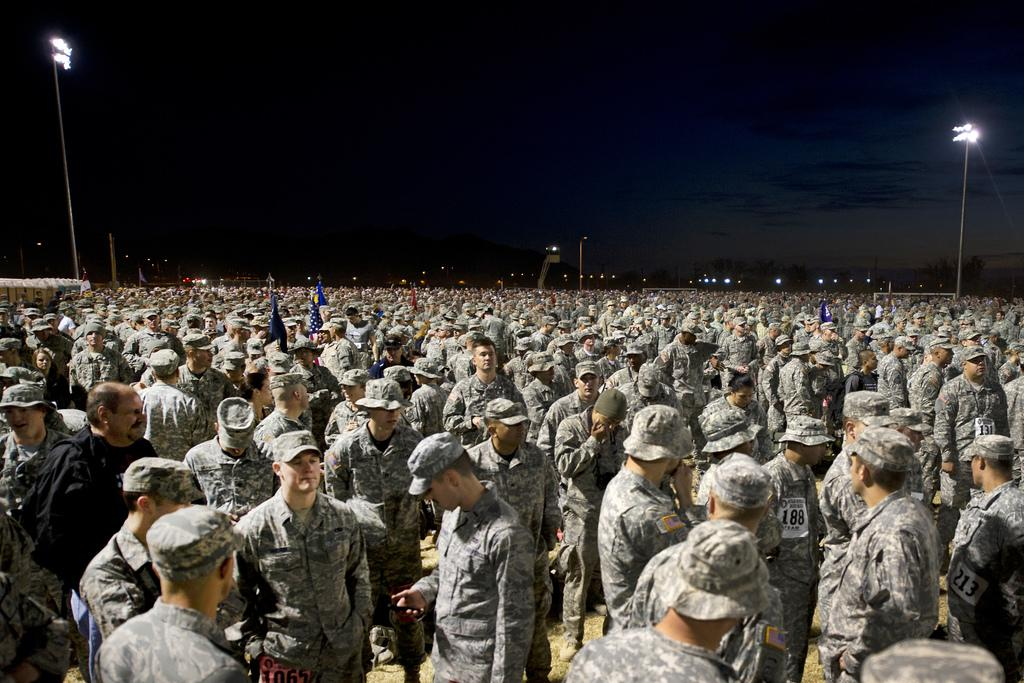What is the main subject of the image? The main subject of the image is a group of people. What can be observed about the attire of the people in the image? Most of the people are wearing military dress and caps. What other objects can be seen in the image? There are light poles and flags in the image. What type of jewel is being used as a chess piece in the image? There is no chess or jewel present in the image; it features a group of people wearing military dress and caps, with light poles and flags in the background. --- Facts: 1. There is a car in the image. 2. The car is parked on the street. 3. There are trees on the side of the street. 4. The sky is visible in the image. 5. There is a traffic light in the image. Absurd Topics: parrot, sandcastle, volcano Conversation: What is the main subject of the image? The main subject of the image is a car. Where is the car located in the image? The car is parked on the street. What can be seen on the side of the street? There are trees on the side of the street. What is visible in the background of the image? The sky is visible in the image. What traffic control device is present in the image? There is a traffic light in the image. Reasoning: Let's think step by step in order to produce the conversation. We start by identifying the main subject of the image, which is the car. Then, we describe the location of the car, noting that it is parked on the street. Next, we mention the presence of trees on the side of the street. We then describe the background of the image, which includes the sky. Finally, we acknowledge the presence of a traffic light in the image. Absurd Question/Answer: Can you tell me how many parrots are sitting on the sandcastle in the image? There are no parrots or sandcastles present in the image; it features a car parked on the street, with trees on the side, the sky in the background, and a traffic light. 